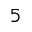<formula> <loc_0><loc_0><loc_500><loc_500>5</formula> 